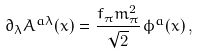<formula> <loc_0><loc_0><loc_500><loc_500>\partial _ { \lambda } A ^ { a \lambda } ( x ) = \frac { f _ { \pi } m _ { \pi } ^ { 2 } } { \sqrt { 2 } } \, \phi ^ { a } ( x ) \, ,</formula> 